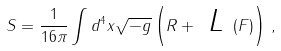Convert formula to latex. <formula><loc_0><loc_0><loc_500><loc_500>S = \frac { 1 } { 1 6 \pi } \int d ^ { 4 } x \sqrt { - g } \left ( R + \emph { L } ( F ) \right ) \, ,</formula> 